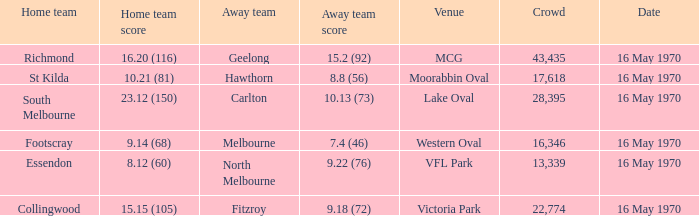Who was the away team at western oval? Melbourne. 